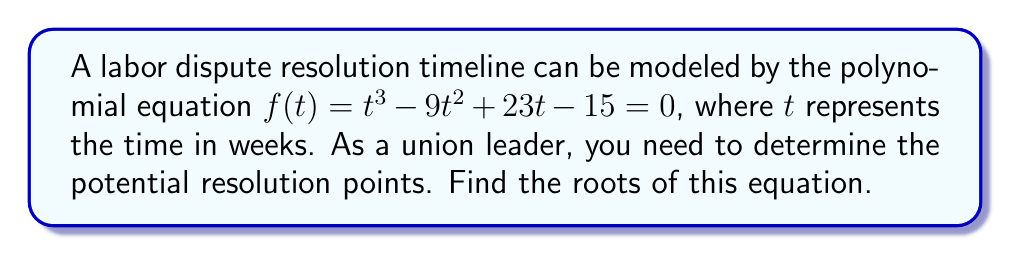Show me your answer to this math problem. To find the roots of the polynomial equation $f(t) = t^3 - 9t^2 + 23t - 15 = 0$, we'll use the rational root theorem and synthetic division.

Step 1: List potential rational roots
The potential rational roots are the factors of the constant term (±15):
±1, ±3, ±5, ±15

Step 2: Use synthetic division to test these roots
Let's start with 1:

$$ \begin{array}{r}
1 \enclose{longdiv}{1 \quad -9 \quad 23 \quad -15} \\
\underline{1 \quad -8 \quad 15} \\
1 \quad -8 \quad 15 \quad 0
\end{array} $$

We found a root: $t = 1$

Step 3: Factor out $(t - 1)$
$t^3 - 9t^2 + 23t - 15 = (t - 1)(t^2 - 8t + 15)$

Step 4: Solve the quadratic equation $t^2 - 8t + 15 = 0$
Using the quadratic formula: $t = \frac{-b \pm \sqrt{b^2 - 4ac}}{2a}$

$t = \frac{8 \pm \sqrt{64 - 60}}{2} = \frac{8 \pm 2}{2}$

$t = 5$ or $t = 3$

Therefore, the roots of the equation are $t = 1$, $t = 3$, and $t = 5$.
Answer: $t = 1$, $t = 3$, $t = 5$ 